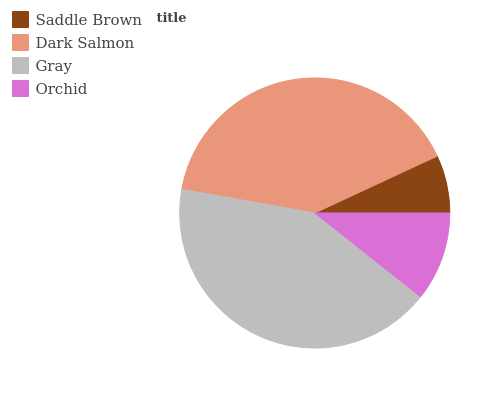Is Saddle Brown the minimum?
Answer yes or no. Yes. Is Gray the maximum?
Answer yes or no. Yes. Is Dark Salmon the minimum?
Answer yes or no. No. Is Dark Salmon the maximum?
Answer yes or no. No. Is Dark Salmon greater than Saddle Brown?
Answer yes or no. Yes. Is Saddle Brown less than Dark Salmon?
Answer yes or no. Yes. Is Saddle Brown greater than Dark Salmon?
Answer yes or no. No. Is Dark Salmon less than Saddle Brown?
Answer yes or no. No. Is Dark Salmon the high median?
Answer yes or no. Yes. Is Orchid the low median?
Answer yes or no. Yes. Is Orchid the high median?
Answer yes or no. No. Is Saddle Brown the low median?
Answer yes or no. No. 